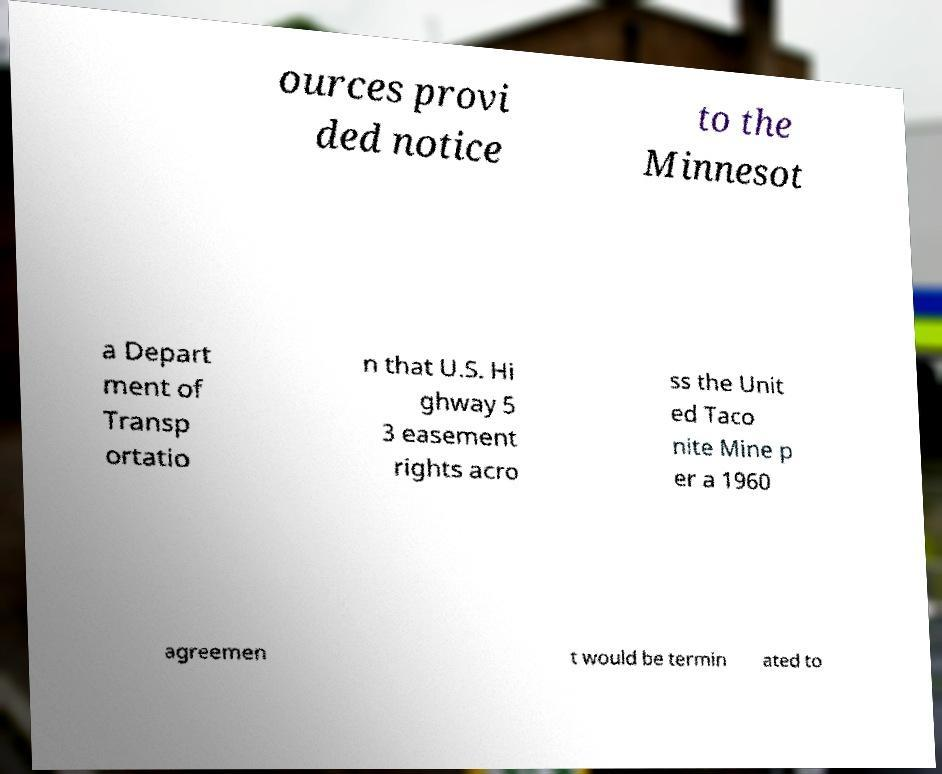Can you accurately transcribe the text from the provided image for me? ources provi ded notice to the Minnesot a Depart ment of Transp ortatio n that U.S. Hi ghway 5 3 easement rights acro ss the Unit ed Taco nite Mine p er a 1960 agreemen t would be termin ated to 